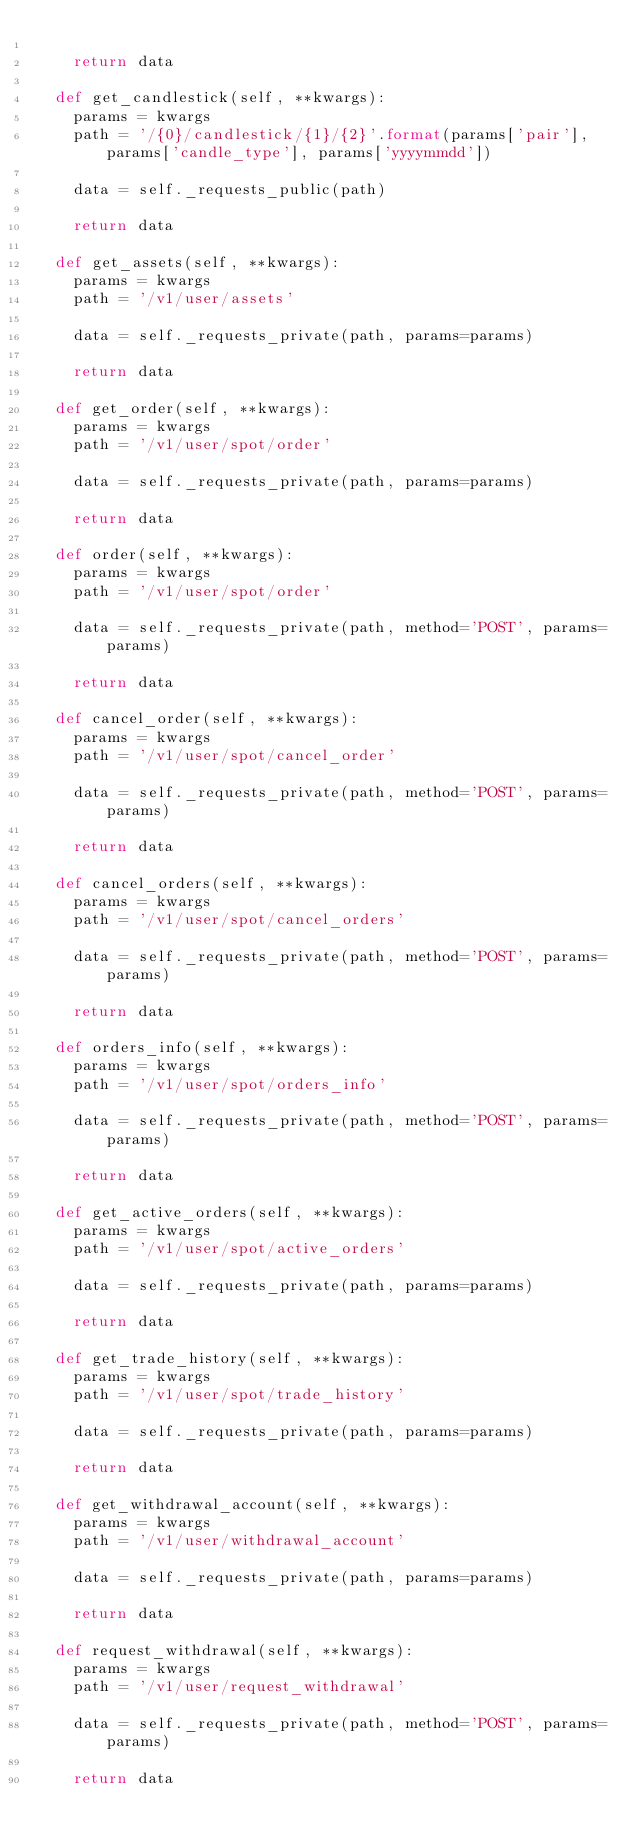<code> <loc_0><loc_0><loc_500><loc_500><_Python_>
		return data

	def get_candlestick(self, **kwargs):
		params = kwargs
		path = '/{0}/candlestick/{1}/{2}'.format(params['pair'], params['candle_type'], params['yyyymmdd'])

		data = self._requests_public(path)

		return data

	def get_assets(self, **kwargs):
		params = kwargs
		path = '/v1/user/assets'

		data = self._requests_private(path, params=params)

		return data

	def get_order(self, **kwargs):
		params = kwargs
		path = '/v1/user/spot/order'

		data = self._requests_private(path, params=params)

		return data

	def order(self, **kwargs):
		params = kwargs
		path = '/v1/user/spot/order'

		data = self._requests_private(path, method='POST', params=params)

		return data

	def cancel_order(self, **kwargs):
		params = kwargs
		path = '/v1/user/spot/cancel_order'

		data = self._requests_private(path, method='POST', params=params)

		return data

	def cancel_orders(self, **kwargs):
		params = kwargs
		path = '/v1/user/spot/cancel_orders'

		data = self._requests_private(path, method='POST', params=params)

		return data

	def orders_info(self, **kwargs):
		params = kwargs
		path = '/v1/user/spot/orders_info'

		data = self._requests_private(path, method='POST', params=params)

		return data

	def get_active_orders(self, **kwargs):
		params = kwargs
		path = '/v1/user/spot/active_orders'

		data = self._requests_private(path, params=params)

		return data

	def get_trade_history(self, **kwargs):
		params = kwargs
		path = '/v1/user/spot/trade_history'

		data = self._requests_private(path, params=params)

		return data

	def get_withdrawal_account(self, **kwargs):
		params = kwargs
		path = '/v1/user/withdrawal_account'

		data = self._requests_private(path, params=params)

		return data

	def request_withdrawal(self, **kwargs):
		params = kwargs
		path = '/v1/user/request_withdrawal'

		data = self._requests_private(path, method='POST', params=params)

		return data
</code> 